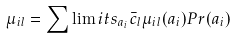Convert formula to latex. <formula><loc_0><loc_0><loc_500><loc_500>\mu _ { i l } = \sum \lim i t s _ { a _ { i } } \bar { c } _ { l } \mu _ { i l } ( a _ { i } ) P r ( a _ { i } )</formula> 